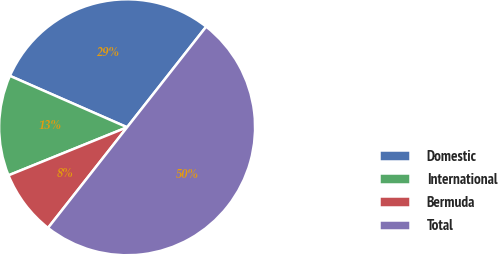<chart> <loc_0><loc_0><loc_500><loc_500><pie_chart><fcel>Domestic<fcel>International<fcel>Bermuda<fcel>Total<nl><fcel>29.02%<fcel>12.71%<fcel>8.27%<fcel>50.0%<nl></chart> 